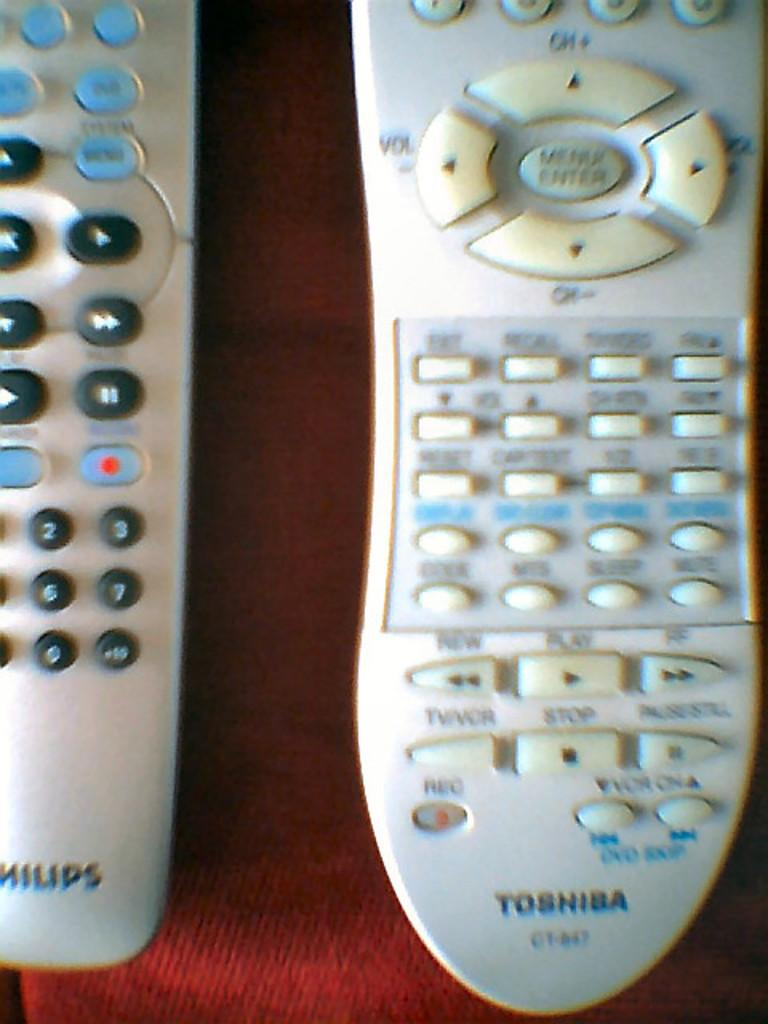<image>
Write a terse but informative summary of the picture. Two remote controls, a Philips and a Toshiba, sit side by side. 